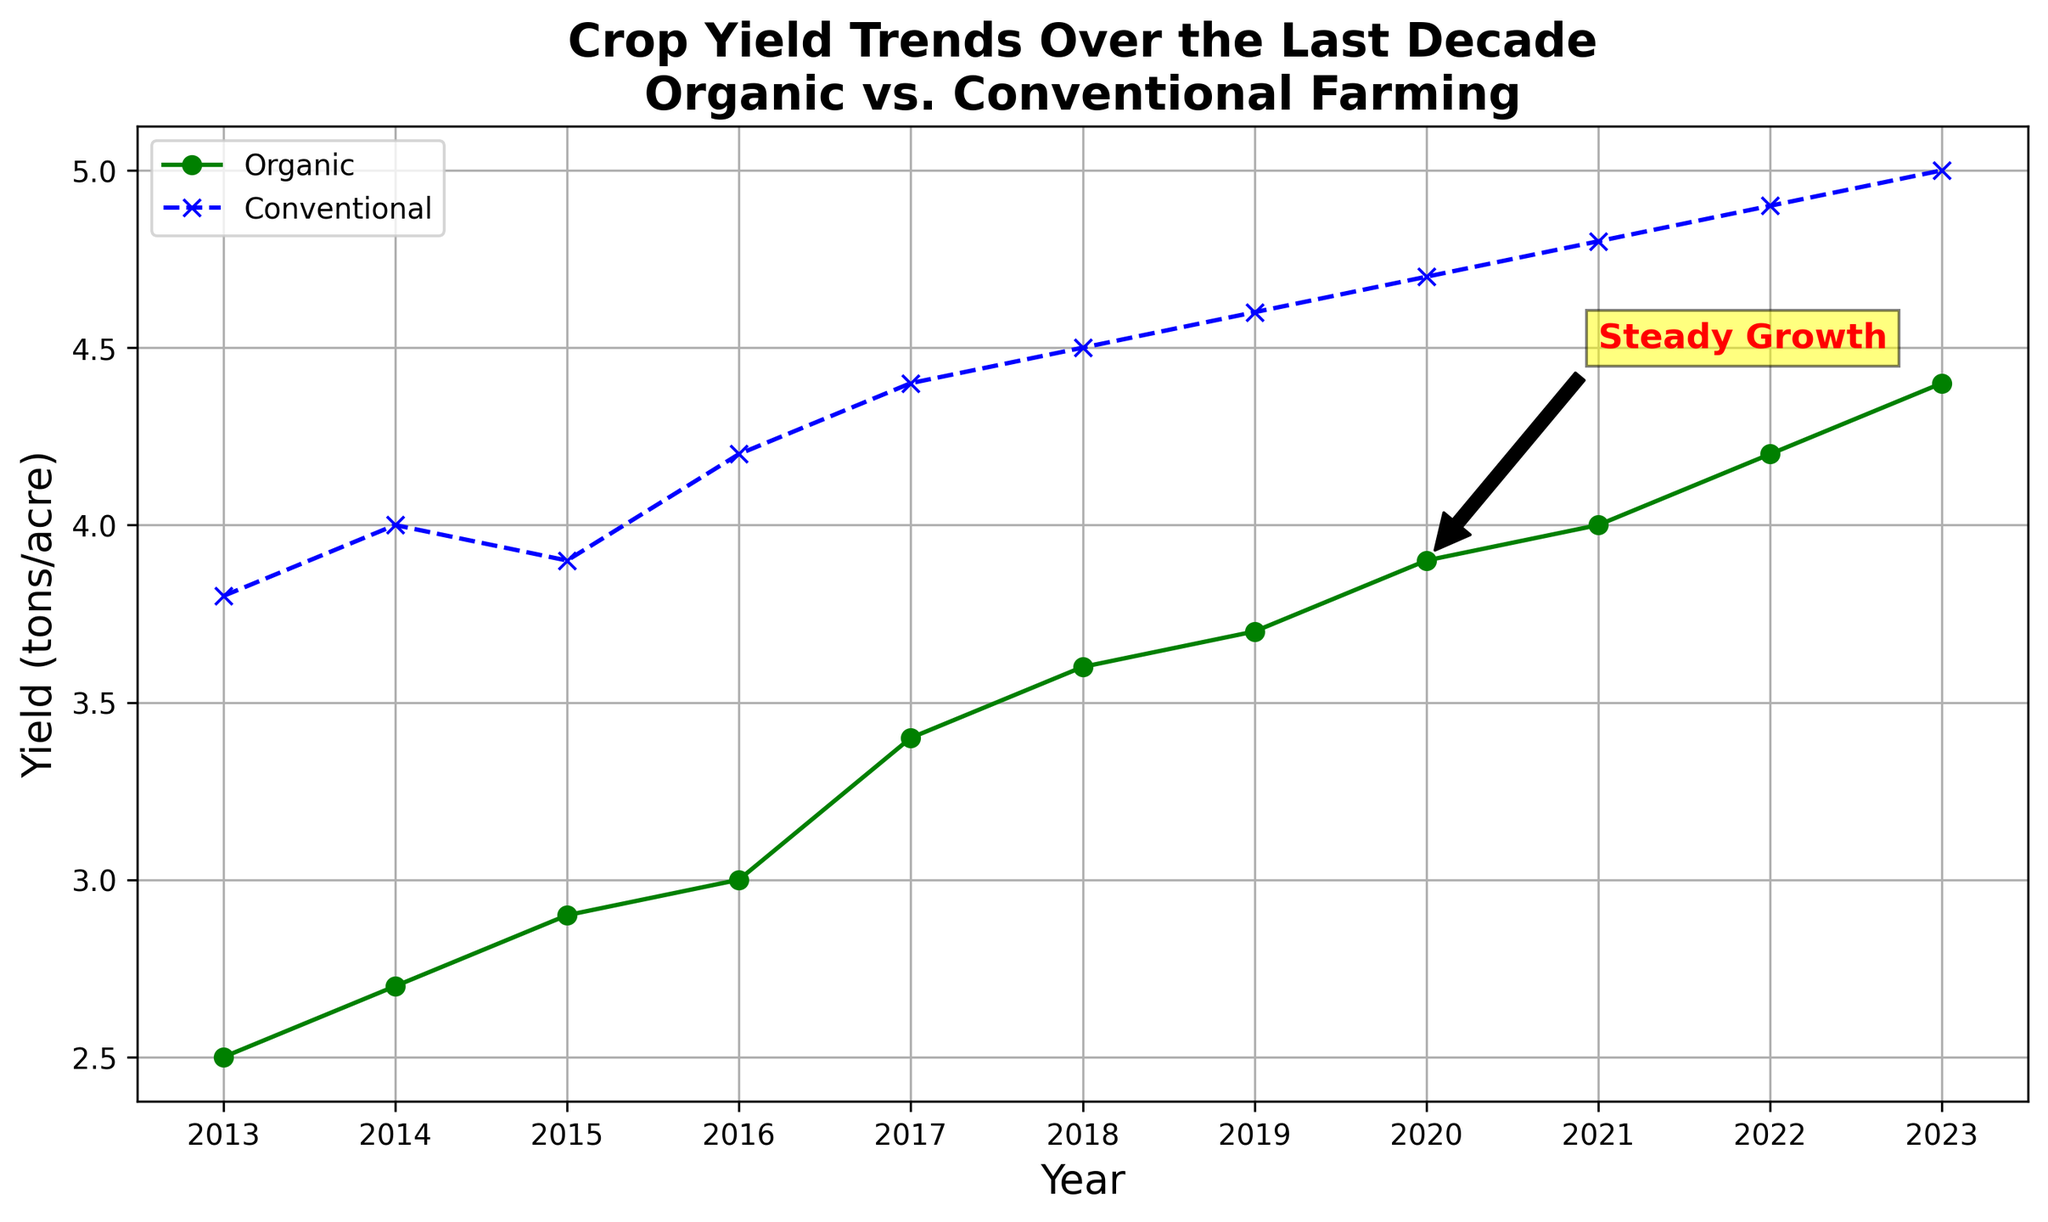What year did the organic farming yield first surpass 4 tons per acre? The plot shows the organic yield as lower than 4 tons per acre through 2020. In 2021, the organic yield reaches 4 tons per acre, which surpasses the 4-ton mark.
Answer: 2021 Which type of farming had a higher yield in 2015, and by how much? In 2015, the plot shows the organic yield at approximately 2.9 tons per acre and the conventional yield at about 3.9 tons per acre. The difference is calculated as 3.9 - 2.9 = 1 ton per acre.
Answer: Conventional by 1 ton per acre What visual feature indicates the period referenced by the text annotation "Steady Growth"? The annotation "Steady Growth" has an arrow pointing at the year 2020 for organic yield and then extending to 2021. This visual feature indicates the period of 2020 to 2021.
Answer: 2020 to 2021 What was the difference in yield between organic and conventional farming in 2023? In the year 2023, the plot shows an organic yield of about 4.4 tons per acre and a conventional yield of about 5.0 tons per acre. The difference is calculated as 5.0 - 4.4 = 0.6 tons per acre.
Answer: 0.6 tons per acre In which year did conventional farming yield the most significant increment, and what was the yield growth? By observing the plot, the biggest jump in conventional yield appears between 2014 and 2015, where it moves from approximately 4.0 to 4.2 tons per acre. The yield growth is 4.2 - 4.0 = 0.2 tons per acre.
Answer: 2016 Between 2013 and 2023, which type of farming showed a more consistent year-over-year yield increase? Comparing the trends, both organic and conventional farming yields increase over the years. However, organic farming shows a steady linear growth each year, compared to more varied fluctuations in conventional farming.
Answer: Organic farming Based on the trends, what can you infer about the yield growth of organic farming compared to conventional farming over the decade? From the graph, organic farming shows a steady and continuous increase in yield every year, while conventional farming also increases but has more fluctuations. Organic farming's growth appears more consistent and steady over the years.
Answer: Organic farming is more consistent and steady in yield growth What is the average yield of organic farming over the decade? Sum the yearly organic yields from 2013 to 2023: 2.5 + 2.7 + 2.9 + 3.0 + 3.4 + 3.6 + 3.7 + 3.9 + 4.0 + 4.2 + 4.4 = 38.3 tons per acre. There are 11 years, so the average is 38.3 / 11 ≈ 3.48 tons per acre.
Answer: Approximately 3.48 tons per acre How did the yield of conventional farming change from 2017 to 2018? Observing the plot, the conventional farming yield in 2017 was about 4.4 tons per acre and increased to about 4.5 tons per acre in 2018.
Answer: Increased by 0.1 tons per acre What can be concluded about the trend in yield difference between organic and conventional farming from 2013 to 2023? The gap between the two yields decreases over time. The difference in yields starts larger in 2013 and narrows progressively through 2023.
Answer: The yield difference is decreasing 